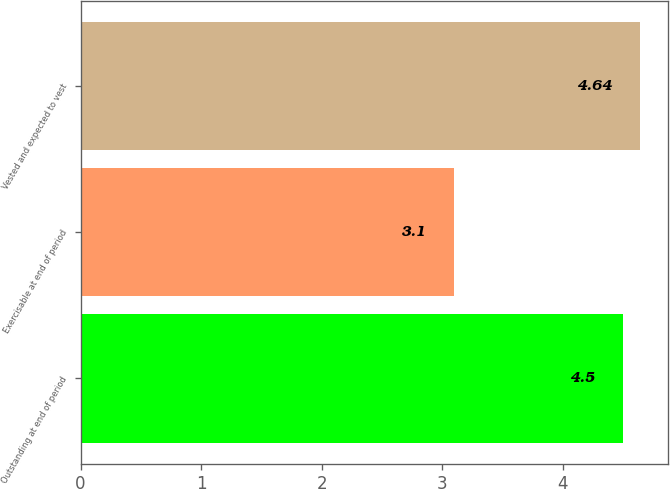<chart> <loc_0><loc_0><loc_500><loc_500><bar_chart><fcel>Outstanding at end of period<fcel>Exercisable at end of period<fcel>Vested and expected to vest<nl><fcel>4.5<fcel>3.1<fcel>4.64<nl></chart> 